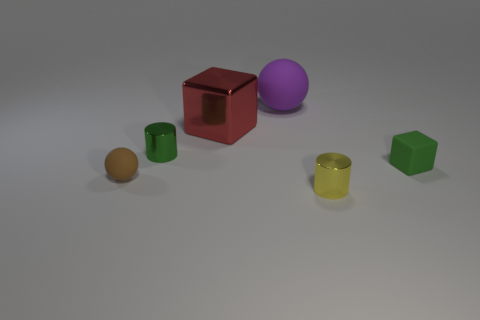Subtract all green cubes. How many cubes are left? 1 Add 3 small yellow things. How many objects exist? 9 Subtract all balls. How many objects are left? 4 Subtract 1 cylinders. How many cylinders are left? 1 Add 1 small cyan blocks. How many small cyan blocks exist? 1 Subtract 1 yellow cylinders. How many objects are left? 5 Subtract all yellow blocks. Subtract all purple balls. How many blocks are left? 2 Subtract all large purple metallic objects. Subtract all brown balls. How many objects are left? 5 Add 3 matte objects. How many matte objects are left? 6 